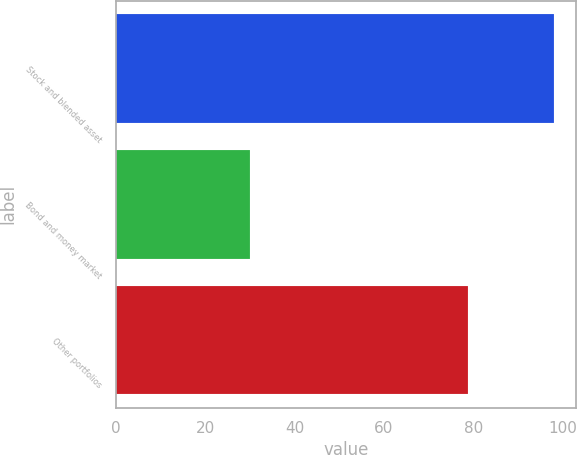<chart> <loc_0><loc_0><loc_500><loc_500><bar_chart><fcel>Stock and blended asset<fcel>Bond and money market<fcel>Other portfolios<nl><fcel>98.1<fcel>30<fcel>78.8<nl></chart> 